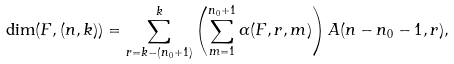<formula> <loc_0><loc_0><loc_500><loc_500>\dim ( F , ( n , k ) ) = \sum _ { r = k - ( n _ { 0 } + 1 ) } ^ { k } \left ( \sum _ { m = 1 } ^ { n _ { 0 } + 1 } \alpha ( F , r , m ) \right ) A ( n - n _ { 0 } - 1 , r ) ,</formula> 